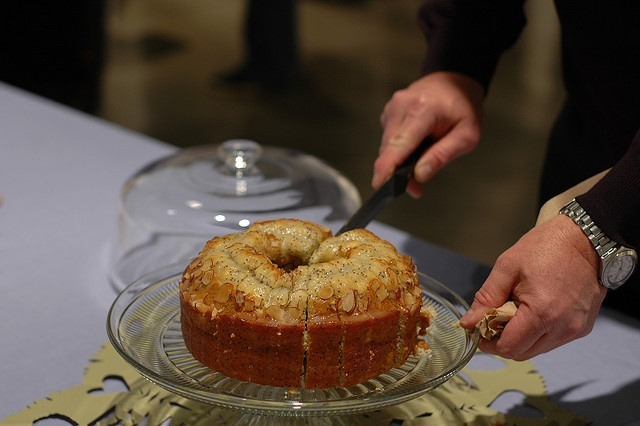Describe the objects in this image and their specific colors. I can see dining table in black, darkgray, and gray tones, people in black, brown, and maroon tones, cake in black, maroon, olive, and tan tones, people in black, tan, and gray tones, and knife in black, gray, and maroon tones in this image. 